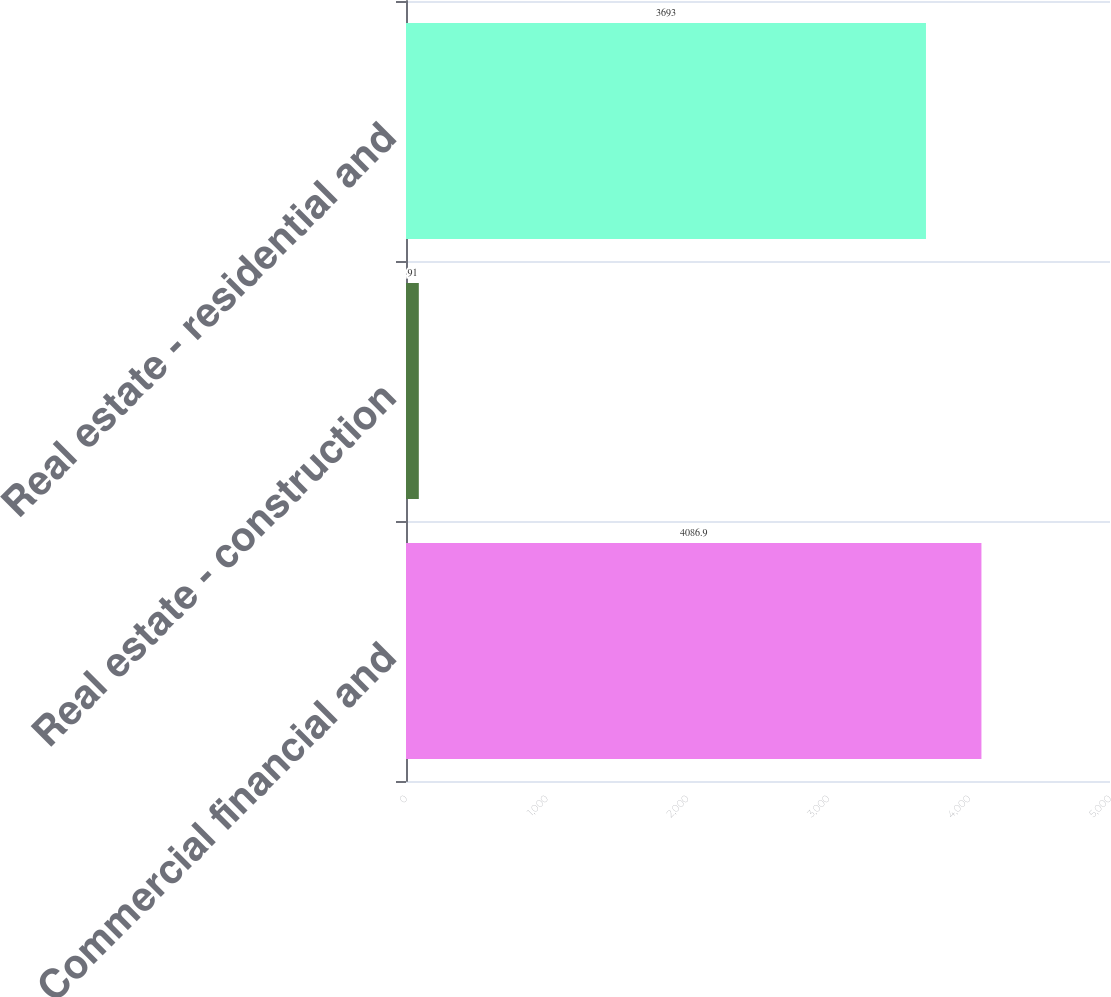Convert chart. <chart><loc_0><loc_0><loc_500><loc_500><bar_chart><fcel>Commercial financial and<fcel>Real estate - construction<fcel>Real estate - residential and<nl><fcel>4086.9<fcel>91<fcel>3693<nl></chart> 